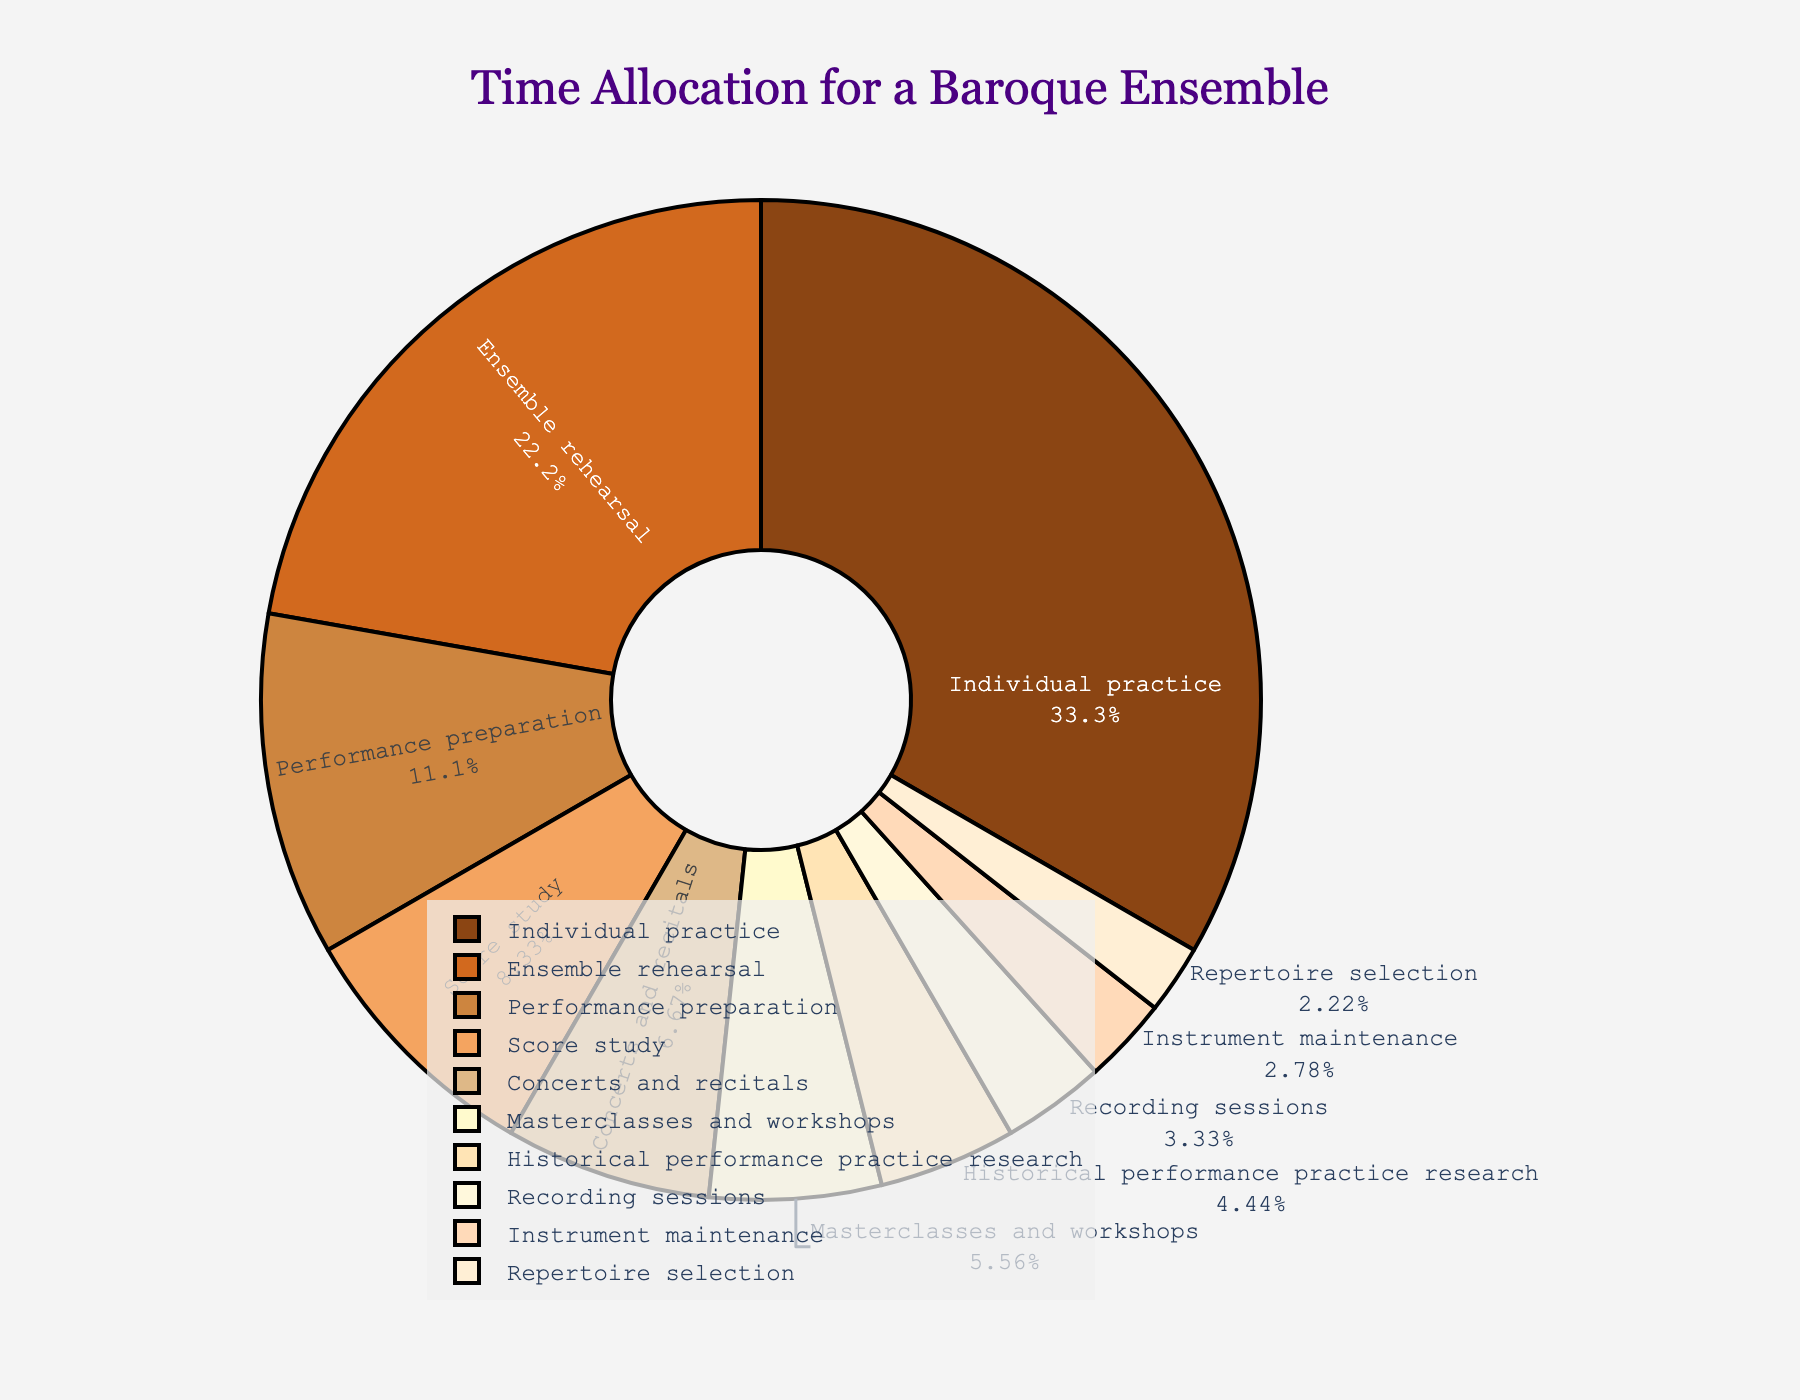What's the activity with the highest time allocation? The activity with the highest time allocation can be identified by looking at the largest section of the pie chart. In this case, it is Individual practice.
Answer: Individual practice What's the total time spent on masterclasses and workshops, historical performance practice research, and recording sessions combined? Masterclasses and workshops (10 hours) + Historical performance practice research (8 hours) + Recording sessions (6 hours) equates to 24 hours.
Answer: 24 hours Which activity has a larger time allocation: performance preparation or ensemble rehearsal? By comparing the segments for performance preparation and ensemble rehearsal, performance preparation is smaller. Thus, ensemble rehearsal has a larger time allocation.
Answer: Ensemble rehearsal How much more time is allocated to individual practice compared to concerts and recitals? Individual practice is 60 hours, and concerts and recitals are 12 hours. The difference is 60 - 12 = 48 hours.
Answer: 48 hours What percentage of time is allocated to instrument maintenance? The segment labeled Instrument maintenance shows the percentage allocation directly on the pie chart.
Answer: 4.2% Is the time spent on score study greater than the time spent on masterclasses and workshops? Score study has 15 hours, and masterclasses and workshops have 10 hours. Using direct comparison, score study is greater.
Answer: Yes What's the average time spent on instrument maintenance, repertoire selection, and recording sessions? Add the times for instrument maintenance (5 hours), repertoire selection (4 hours), and recording sessions (6 hours), then divide by the number of activities: (5 + 4 + 6) / 3 = 15 / 3 = 5 hours.
Answer: 5 hours Which activity has the smallest time allocation, and how much time is allocated to it? The smallest segment on the pie chart represents Repertoire selection, which has 4 hours allocated to it.
Answer: Repertoire selection, 4 hours 